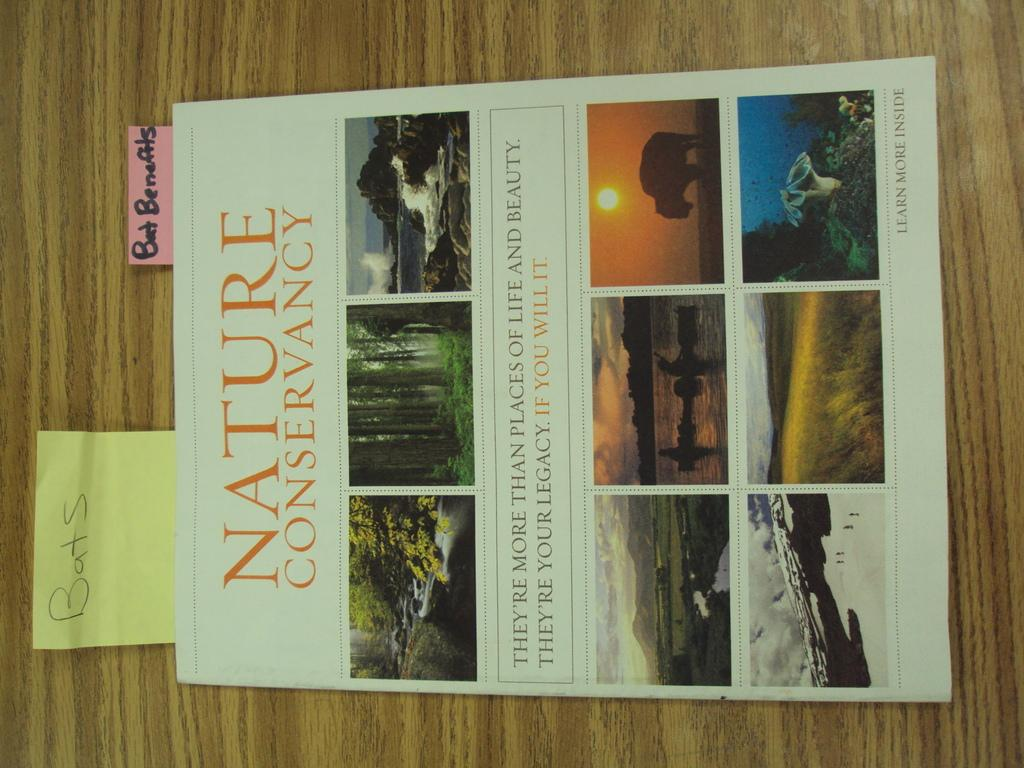<image>
Present a compact description of the photo's key features. a nature conservancy book sitting on a surface 